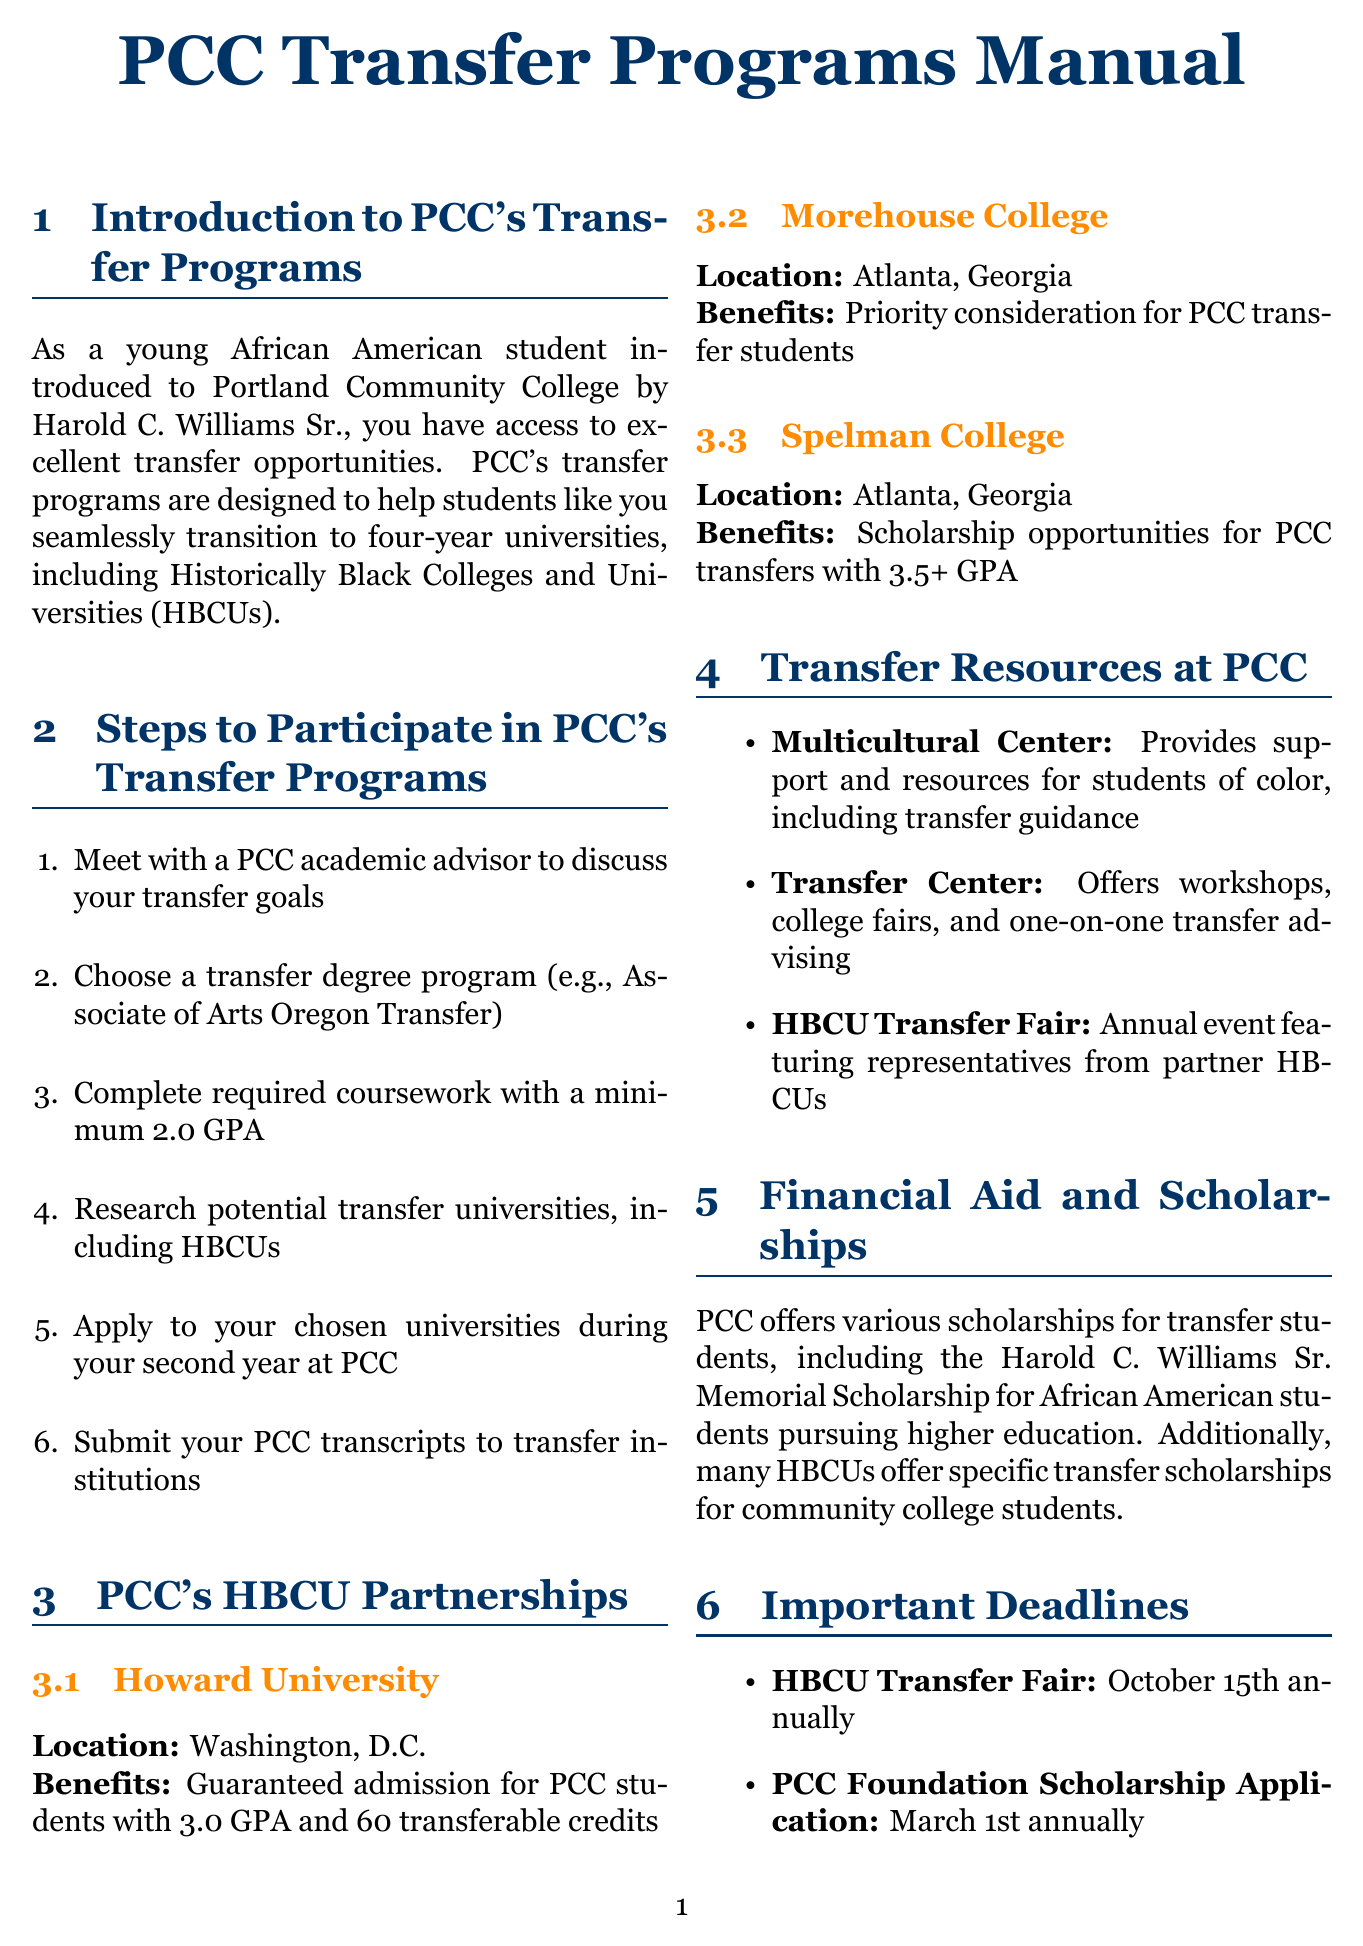What is the location of Howard University? Howard University is located in Washington, D.C., as specified in the HBCU partnerships section.
Answer: Washington, D.C What is the minimum GPA required for guaranteed admission to Howard University? The document states that a minimum GPA of 3.0 is required for guaranteed admission for PCC students to Howard University.
Answer: 3.0 What is the date of the HBCU Transfer Fair? The manual specifies that the HBCU Transfer Fair occurs on October 15th annually.
Answer: October 15th Who is the memorable scholarship named after in the financial aid section? The financial aid section mentions the Harold C. Williams Sr. Memorial Scholarship, which is named after Harold C. Williams Sr.
Answer: Harold C. Williams Sr What type of support does the Multicultural Center provide? The document describes the Multicultural Center as providing support and resources for students of color, including transfer guidance.
Answer: Transfer guidance What is the transfer degree program mentioned in the steps to participate? The steps mention the Associate of Arts Oregon Transfer as a transfer degree program option.
Answer: Associate of Arts Oregon Transfer What major did Jasmine Thompson pursue after transferring? The success stories section indicates that Jasmine Thompson pursued a major in Political Science after transferring.
Answer: Political Science Which college offers scholarship opportunities for PCC transfers with a GPA over 3.5? According to the HBCU partnerships section, Spelman College offers scholarship opportunities for PCC transfers with a GPA of 3.5 or higher.
Answer: Spelman College What event features representatives from partner HBCUs? The document mentions the HBCU Transfer Fair as the event that features representatives from partner HBCUs.
Answer: HBCU Transfer Fair 